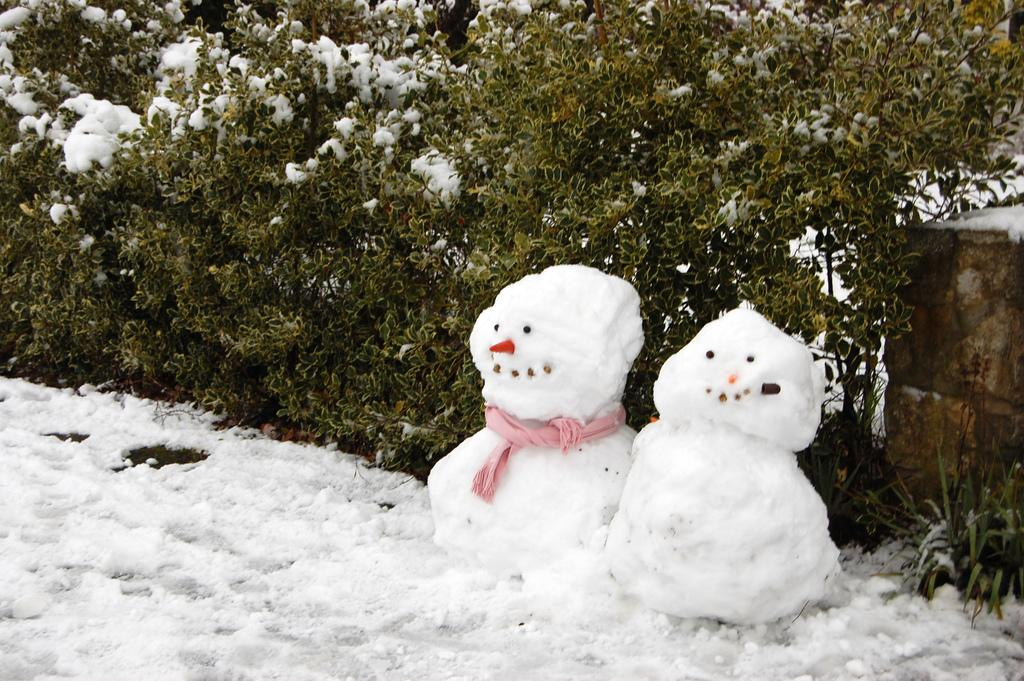What type of dolls are in the image? There are two snow dolls in the image. What color are the mufflers around the snow dolls' necks? The snow dolls have pink color mufflers around their necks. Where are the snow dolls located? The snow dolls are on a snow ground. What other celestial objects are visible in the image besides the snow dolls? There are planets visible in the image. What is the condition of the planets in the image? The planets are covered in snow. Can you tell me how many celery sticks are being used as furniture in the image? There is no celery or furniture present in the image. 